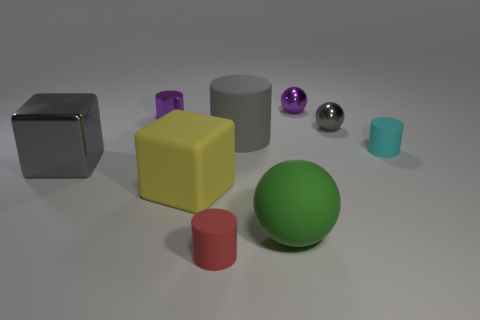What number of objects are metallic objects to the right of the green matte object or gray metallic things behind the cyan cylinder?
Ensure brevity in your answer.  2. Are there any other things of the same color as the large matte sphere?
Make the answer very short. No. What color is the tiny matte object that is right of the rubber cylinder behind the cyan thing that is behind the yellow thing?
Make the answer very short. Cyan. What size is the gray metallic object that is on the right side of the tiny purple thing on the right side of the large matte block?
Offer a terse response. Small. There is a large thing that is both to the right of the red object and behind the green matte ball; what material is it?
Provide a succinct answer. Rubber. Does the gray metallic block have the same size as the purple thing to the right of the large sphere?
Your response must be concise. No. Are there any large green balls?
Your answer should be compact. Yes. There is another thing that is the same shape as the big gray metal thing; what is its material?
Ensure brevity in your answer.  Rubber. What is the size of the purple metal thing that is on the left side of the large block to the right of the gray shiny object that is left of the green matte object?
Your answer should be compact. Small. Are there any green rubber balls behind the yellow cube?
Keep it short and to the point. No. 